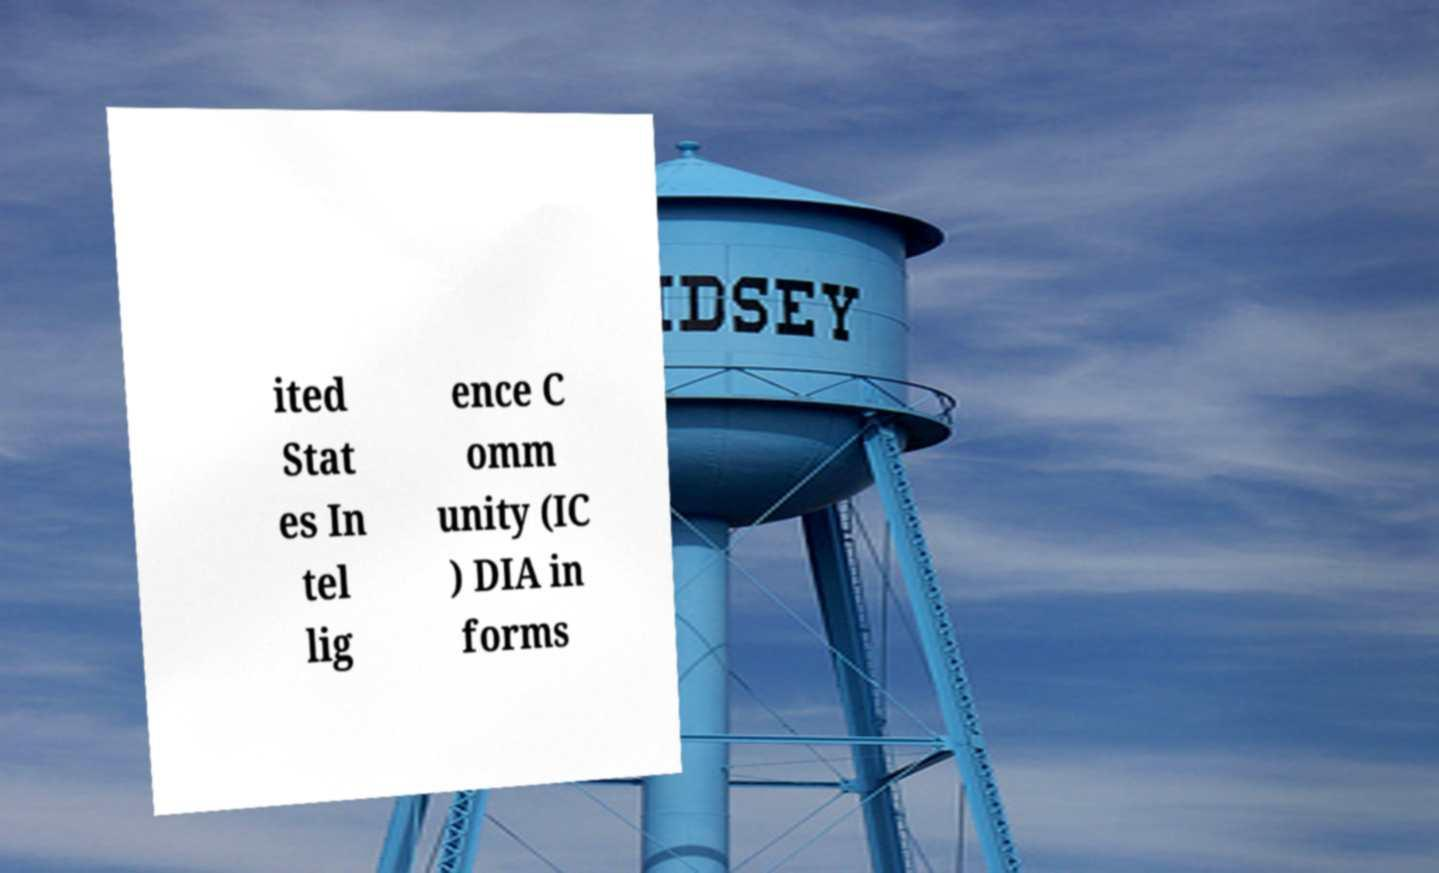What messages or text are displayed in this image? I need them in a readable, typed format. ited Stat es In tel lig ence C omm unity (IC ) DIA in forms 